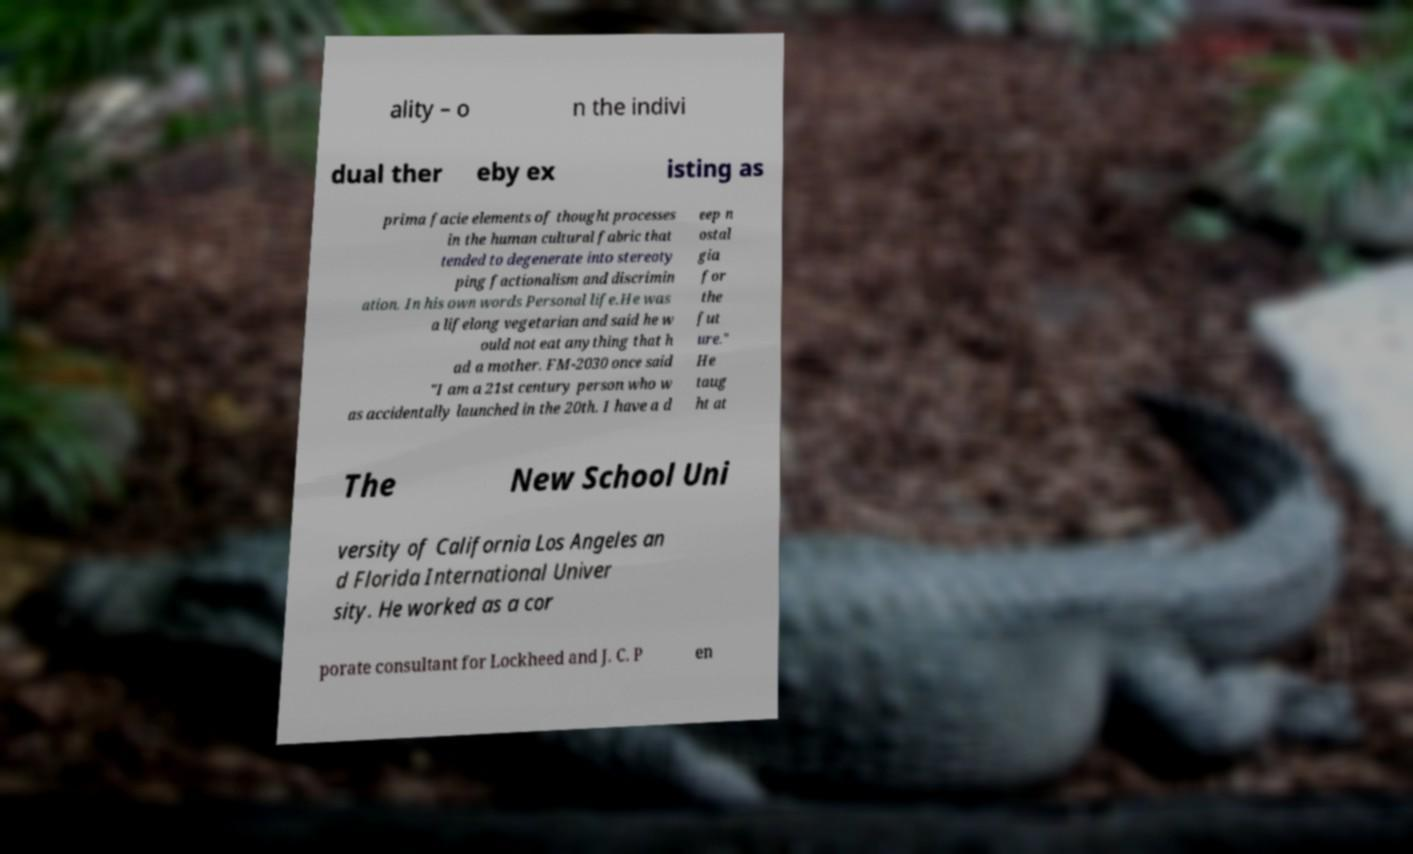Could you extract and type out the text from this image? ality – o n the indivi dual ther eby ex isting as prima facie elements of thought processes in the human cultural fabric that tended to degenerate into stereoty ping factionalism and discrimin ation. In his own words Personal life.He was a lifelong vegetarian and said he w ould not eat anything that h ad a mother. FM-2030 once said "I am a 21st century person who w as accidentally launched in the 20th. I have a d eep n ostal gia for the fut ure." He taug ht at The New School Uni versity of California Los Angeles an d Florida International Univer sity. He worked as a cor porate consultant for Lockheed and J. C. P en 